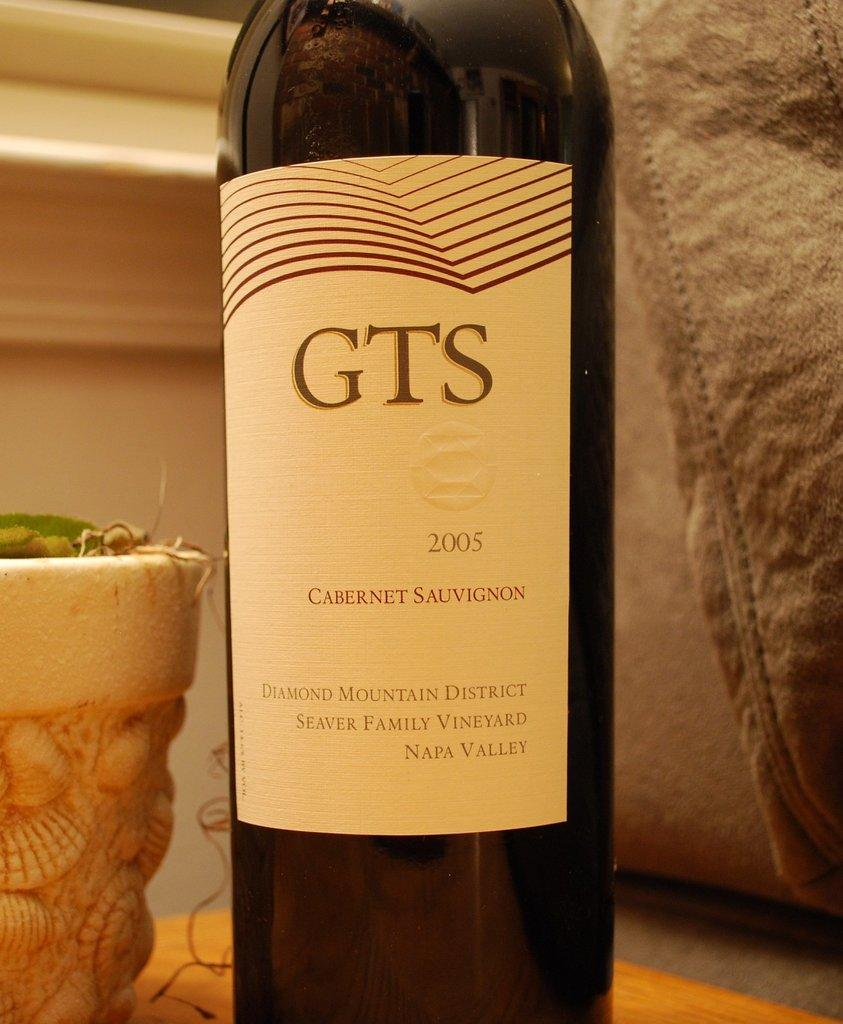<image>
Give a short and clear explanation of the subsequent image. Bottle of wine that says the letters GTS on it. 